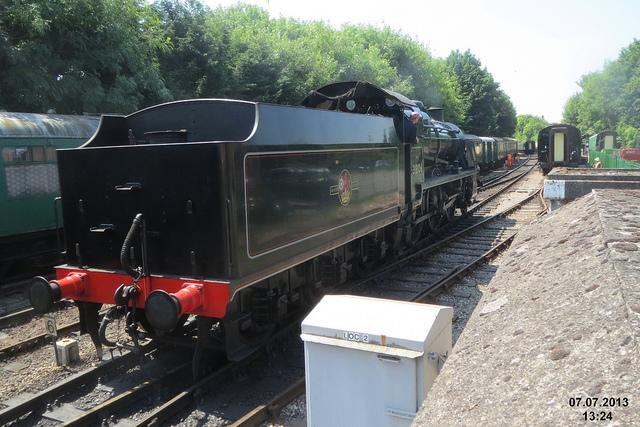The purpose of the train car behind the train engine is to hold what? coal 